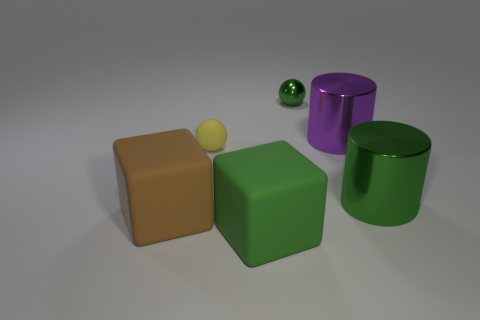Subtract 1 blocks. How many blocks are left? 1 Subtract all cubes. How many objects are left? 4 Subtract all blue balls. How many yellow blocks are left? 0 Subtract all green blocks. Subtract all tiny yellow objects. How many objects are left? 4 Add 5 big purple shiny cylinders. How many big purple shiny cylinders are left? 6 Add 3 green metallic things. How many green metallic things exist? 5 Add 1 tiny green metal objects. How many objects exist? 7 Subtract all green balls. How many balls are left? 1 Subtract 0 brown cylinders. How many objects are left? 6 Subtract all green balls. Subtract all red cubes. How many balls are left? 1 